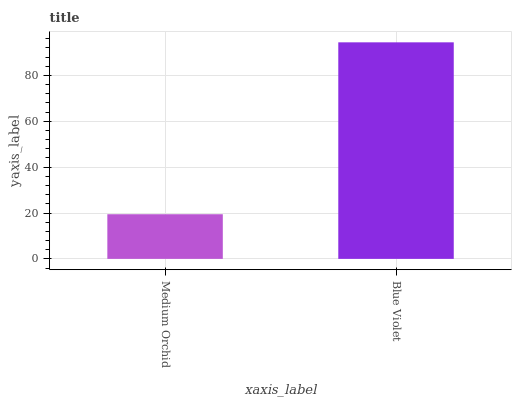Is Medium Orchid the minimum?
Answer yes or no. Yes. Is Blue Violet the maximum?
Answer yes or no. Yes. Is Blue Violet the minimum?
Answer yes or no. No. Is Blue Violet greater than Medium Orchid?
Answer yes or no. Yes. Is Medium Orchid less than Blue Violet?
Answer yes or no. Yes. Is Medium Orchid greater than Blue Violet?
Answer yes or no. No. Is Blue Violet less than Medium Orchid?
Answer yes or no. No. Is Blue Violet the high median?
Answer yes or no. Yes. Is Medium Orchid the low median?
Answer yes or no. Yes. Is Medium Orchid the high median?
Answer yes or no. No. Is Blue Violet the low median?
Answer yes or no. No. 